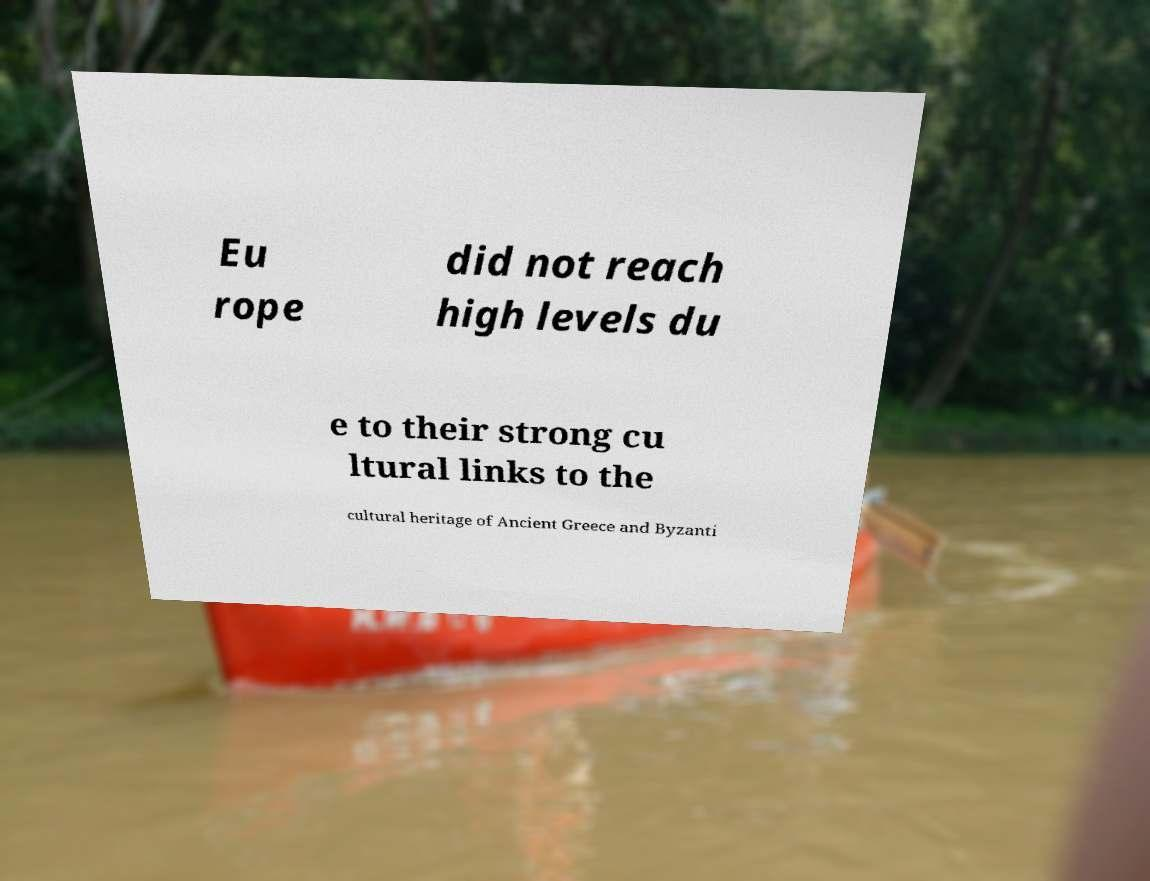Please identify and transcribe the text found in this image. Eu rope did not reach high levels du e to their strong cu ltural links to the cultural heritage of Ancient Greece and Byzanti 